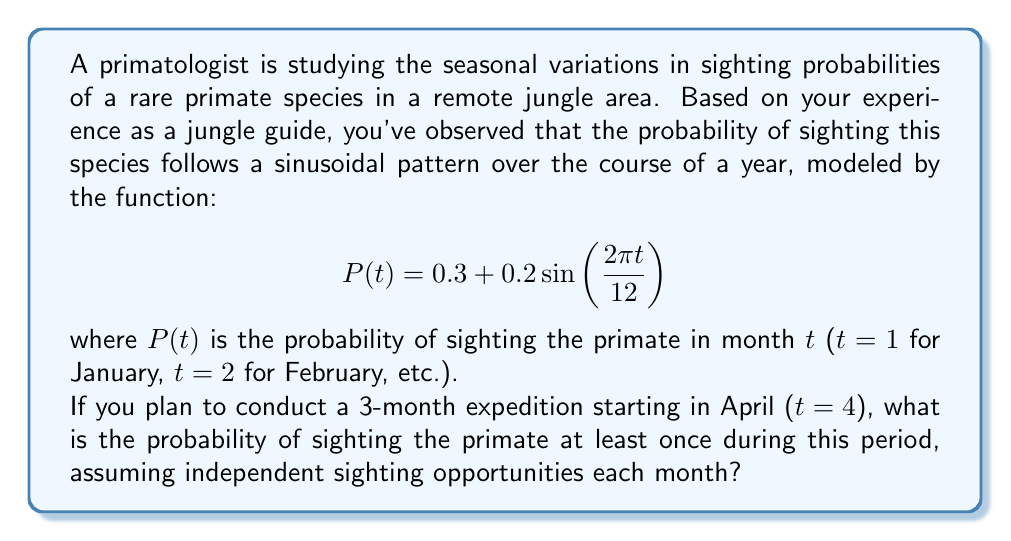Could you help me with this problem? Let's approach this step-by-step:

1) First, we need to calculate the probability of sighting for each month of the expedition:

   For April (t = 4):
   $$P(4) = 0.3 + 0.2\sin\left(\frac{2\pi \cdot 4}{12}\right) = 0.3 + 0.2\sin\left(\frac{2\pi}{3}\right) \approx 0.4732$$

   For May (t = 5):
   $$P(5) = 0.3 + 0.2\sin\left(\frac{2\pi \cdot 5}{12}\right) = 0.3 + 0.2\sin\left(\frac{5\pi}{6}\right) \approx 0.4866$$

   For June (t = 6):
   $$P(6) = 0.3 + 0.2\sin\left(\frac{2\pi \cdot 6}{12}\right) = 0.3 + 0.2\sin(\pi) = 0.3$$

2) Now, we need to calculate the probability of not sighting the primate in each month:

   April: $1 - 0.4732 \approx 0.5268$
   May: $1 - 0.4866 \approx 0.5134$
   June: $1 - 0.3 = 0.7$

3) The probability of not sighting the primate at all during the 3-month period is the product of these probabilities:

   $$0.5268 \cdot 0.5134 \cdot 0.7 \approx 0.1892$$

4) Therefore, the probability of sighting the primate at least once is:

   $$1 - 0.1892 = 0.8108$$
Answer: $0.8108$ or approximately $81.08\%$ 